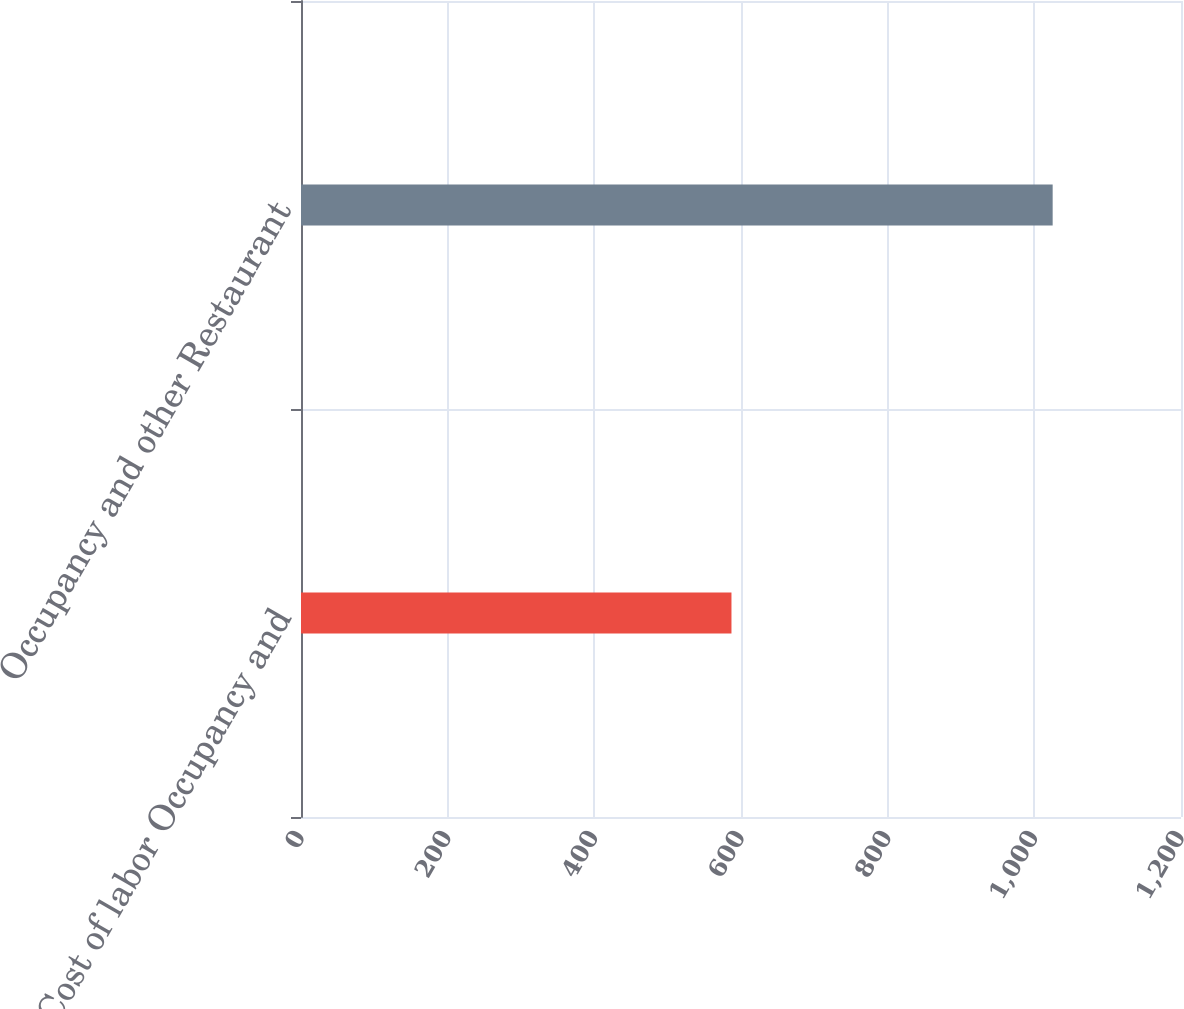Convert chart. <chart><loc_0><loc_0><loc_500><loc_500><bar_chart><fcel>Cost of labor Occupancy and<fcel>Occupancy and other Restaurant<nl><fcel>587<fcel>1025<nl></chart> 